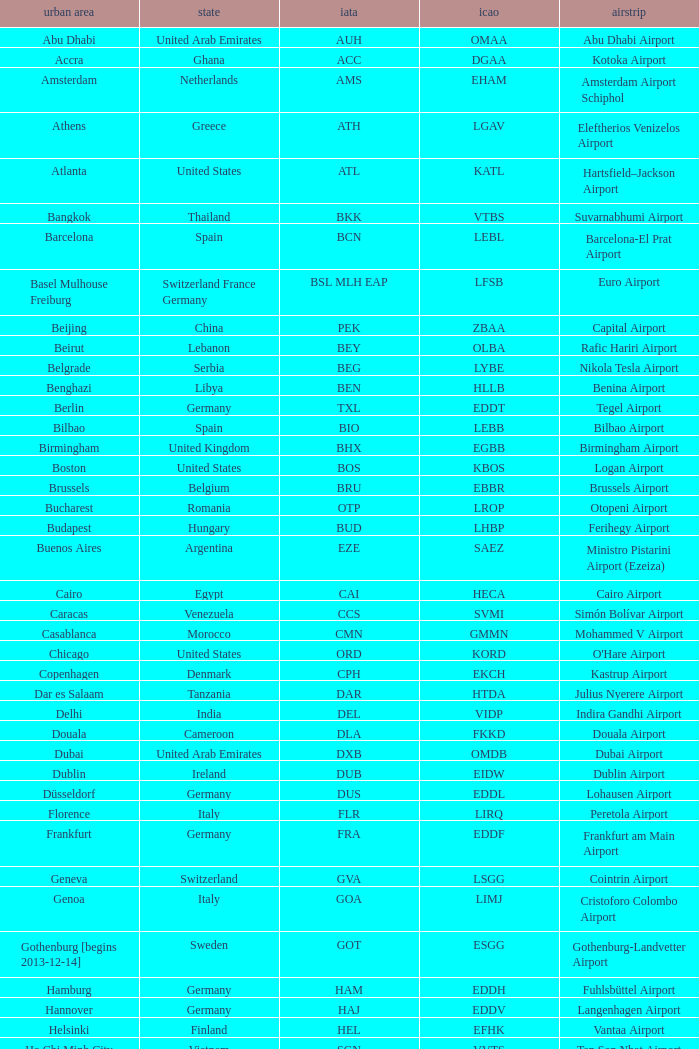What city is fuhlsbüttel airport in? Hamburg. Would you mind parsing the complete table? {'header': ['urban area', 'state', 'iata', 'icao', 'airstrip'], 'rows': [['Abu Dhabi', 'United Arab Emirates', 'AUH', 'OMAA', 'Abu Dhabi Airport'], ['Accra', 'Ghana', 'ACC', 'DGAA', 'Kotoka Airport'], ['Amsterdam', 'Netherlands', 'AMS', 'EHAM', 'Amsterdam Airport Schiphol'], ['Athens', 'Greece', 'ATH', 'LGAV', 'Eleftherios Venizelos Airport'], ['Atlanta', 'United States', 'ATL', 'KATL', 'Hartsfield–Jackson Airport'], ['Bangkok', 'Thailand', 'BKK', 'VTBS', 'Suvarnabhumi Airport'], ['Barcelona', 'Spain', 'BCN', 'LEBL', 'Barcelona-El Prat Airport'], ['Basel Mulhouse Freiburg', 'Switzerland France Germany', 'BSL MLH EAP', 'LFSB', 'Euro Airport'], ['Beijing', 'China', 'PEK', 'ZBAA', 'Capital Airport'], ['Beirut', 'Lebanon', 'BEY', 'OLBA', 'Rafic Hariri Airport'], ['Belgrade', 'Serbia', 'BEG', 'LYBE', 'Nikola Tesla Airport'], ['Benghazi', 'Libya', 'BEN', 'HLLB', 'Benina Airport'], ['Berlin', 'Germany', 'TXL', 'EDDT', 'Tegel Airport'], ['Bilbao', 'Spain', 'BIO', 'LEBB', 'Bilbao Airport'], ['Birmingham', 'United Kingdom', 'BHX', 'EGBB', 'Birmingham Airport'], ['Boston', 'United States', 'BOS', 'KBOS', 'Logan Airport'], ['Brussels', 'Belgium', 'BRU', 'EBBR', 'Brussels Airport'], ['Bucharest', 'Romania', 'OTP', 'LROP', 'Otopeni Airport'], ['Budapest', 'Hungary', 'BUD', 'LHBP', 'Ferihegy Airport'], ['Buenos Aires', 'Argentina', 'EZE', 'SAEZ', 'Ministro Pistarini Airport (Ezeiza)'], ['Cairo', 'Egypt', 'CAI', 'HECA', 'Cairo Airport'], ['Caracas', 'Venezuela', 'CCS', 'SVMI', 'Simón Bolívar Airport'], ['Casablanca', 'Morocco', 'CMN', 'GMMN', 'Mohammed V Airport'], ['Chicago', 'United States', 'ORD', 'KORD', "O'Hare Airport"], ['Copenhagen', 'Denmark', 'CPH', 'EKCH', 'Kastrup Airport'], ['Dar es Salaam', 'Tanzania', 'DAR', 'HTDA', 'Julius Nyerere Airport'], ['Delhi', 'India', 'DEL', 'VIDP', 'Indira Gandhi Airport'], ['Douala', 'Cameroon', 'DLA', 'FKKD', 'Douala Airport'], ['Dubai', 'United Arab Emirates', 'DXB', 'OMDB', 'Dubai Airport'], ['Dublin', 'Ireland', 'DUB', 'EIDW', 'Dublin Airport'], ['Düsseldorf', 'Germany', 'DUS', 'EDDL', 'Lohausen Airport'], ['Florence', 'Italy', 'FLR', 'LIRQ', 'Peretola Airport'], ['Frankfurt', 'Germany', 'FRA', 'EDDF', 'Frankfurt am Main Airport'], ['Geneva', 'Switzerland', 'GVA', 'LSGG', 'Cointrin Airport'], ['Genoa', 'Italy', 'GOA', 'LIMJ', 'Cristoforo Colombo Airport'], ['Gothenburg [begins 2013-12-14]', 'Sweden', 'GOT', 'ESGG', 'Gothenburg-Landvetter Airport'], ['Hamburg', 'Germany', 'HAM', 'EDDH', 'Fuhlsbüttel Airport'], ['Hannover', 'Germany', 'HAJ', 'EDDV', 'Langenhagen Airport'], ['Helsinki', 'Finland', 'HEL', 'EFHK', 'Vantaa Airport'], ['Ho Chi Minh City', 'Vietnam', 'SGN', 'VVTS', 'Tan Son Nhat Airport'], ['Hong Kong', 'Hong Kong', 'HKG', 'VHHH', 'Chek Lap Kok Airport'], ['Istanbul', 'Turkey', 'IST', 'LTBA', 'Atatürk Airport'], ['Jakarta', 'Indonesia', 'CGK', 'WIII', 'Soekarno–Hatta Airport'], ['Jeddah', 'Saudi Arabia', 'JED', 'OEJN', 'King Abdulaziz Airport'], ['Johannesburg', 'South Africa', 'JNB', 'FAJS', 'OR Tambo Airport'], ['Karachi', 'Pakistan', 'KHI', 'OPKC', 'Jinnah Airport'], ['Kiev', 'Ukraine', 'KBP', 'UKBB', 'Boryspil International Airport'], ['Lagos', 'Nigeria', 'LOS', 'DNMM', 'Murtala Muhammed Airport'], ['Libreville', 'Gabon', 'LBV', 'FOOL', "Leon M'ba Airport"], ['Lisbon', 'Portugal', 'LIS', 'LPPT', 'Portela Airport'], ['London', 'United Kingdom', 'LCY', 'EGLC', 'City Airport'], ['London [begins 2013-12-14]', 'United Kingdom', 'LGW', 'EGKK', 'Gatwick Airport'], ['London', 'United Kingdom', 'LHR', 'EGLL', 'Heathrow Airport'], ['Los Angeles', 'United States', 'LAX', 'KLAX', 'Los Angeles International Airport'], ['Lugano', 'Switzerland', 'LUG', 'LSZA', 'Agno Airport'], ['Luxembourg City', 'Luxembourg', 'LUX', 'ELLX', 'Findel Airport'], ['Lyon', 'France', 'LYS', 'LFLL', 'Saint-Exupéry Airport'], ['Madrid', 'Spain', 'MAD', 'LEMD', 'Madrid-Barajas Airport'], ['Malabo', 'Equatorial Guinea', 'SSG', 'FGSL', 'Saint Isabel Airport'], ['Malaga', 'Spain', 'AGP', 'LEMG', 'Málaga-Costa del Sol Airport'], ['Manchester', 'United Kingdom', 'MAN', 'EGCC', 'Ringway Airport'], ['Manila', 'Philippines', 'MNL', 'RPLL', 'Ninoy Aquino Airport'], ['Marrakech [begins 2013-11-01]', 'Morocco', 'RAK', 'GMMX', 'Menara Airport'], ['Miami', 'United States', 'MIA', 'KMIA', 'Miami Airport'], ['Milan', 'Italy', 'MXP', 'LIMC', 'Malpensa Airport'], ['Minneapolis', 'United States', 'MSP', 'KMSP', 'Minneapolis Airport'], ['Montreal', 'Canada', 'YUL', 'CYUL', 'Pierre Elliott Trudeau Airport'], ['Moscow', 'Russia', 'DME', 'UUDD', 'Domodedovo Airport'], ['Mumbai', 'India', 'BOM', 'VABB', 'Chhatrapati Shivaji Airport'], ['Munich', 'Germany', 'MUC', 'EDDM', 'Franz Josef Strauss Airport'], ['Muscat', 'Oman', 'MCT', 'OOMS', 'Seeb Airport'], ['Nairobi', 'Kenya', 'NBO', 'HKJK', 'Jomo Kenyatta Airport'], ['Newark', 'United States', 'EWR', 'KEWR', 'Liberty Airport'], ['New York City', 'United States', 'JFK', 'KJFK', 'John F Kennedy Airport'], ['Nice', 'France', 'NCE', 'LFMN', "Côte d'Azur Airport"], ['Nuremberg', 'Germany', 'NUE', 'EDDN', 'Nuremberg Airport'], ['Oslo', 'Norway', 'OSL', 'ENGM', 'Gardermoen Airport'], ['Palma de Mallorca', 'Spain', 'PMI', 'LFPA', 'Palma de Mallorca Airport'], ['Paris', 'France', 'CDG', 'LFPG', 'Charles de Gaulle Airport'], ['Porto', 'Portugal', 'OPO', 'LPPR', 'Francisco de Sa Carneiro Airport'], ['Prague', 'Czech Republic', 'PRG', 'LKPR', 'Ruzyně Airport'], ['Riga', 'Latvia', 'RIX', 'EVRA', 'Riga Airport'], ['Rio de Janeiro [resumes 2014-7-14]', 'Brazil', 'GIG', 'SBGL', 'Galeão Airport'], ['Riyadh', 'Saudi Arabia', 'RUH', 'OERK', 'King Khalid Airport'], ['Rome', 'Italy', 'FCO', 'LIRF', 'Leonardo da Vinci Airport'], ['Saint Petersburg', 'Russia', 'LED', 'ULLI', 'Pulkovo Airport'], ['San Francisco', 'United States', 'SFO', 'KSFO', 'San Francisco Airport'], ['Santiago', 'Chile', 'SCL', 'SCEL', 'Comodoro Arturo Benitez Airport'], ['São Paulo', 'Brazil', 'GRU', 'SBGR', 'Guarulhos Airport'], ['Sarajevo', 'Bosnia and Herzegovina', 'SJJ', 'LQSA', 'Butmir Airport'], ['Seattle', 'United States', 'SEA', 'KSEA', 'Sea-Tac Airport'], ['Shanghai', 'China', 'PVG', 'ZSPD', 'Pudong Airport'], ['Singapore', 'Singapore', 'SIN', 'WSSS', 'Changi Airport'], ['Skopje', 'Republic of Macedonia', 'SKP', 'LWSK', 'Alexander the Great Airport'], ['Sofia', 'Bulgaria', 'SOF', 'LBSF', 'Vrazhdebna Airport'], ['Stockholm', 'Sweden', 'ARN', 'ESSA', 'Arlanda Airport'], ['Stuttgart', 'Germany', 'STR', 'EDDS', 'Echterdingen Airport'], ['Taipei', 'Taiwan', 'TPE', 'RCTP', 'Taoyuan Airport'], ['Tehran', 'Iran', 'IKA', 'OIIE', 'Imam Khomeini Airport'], ['Tel Aviv', 'Israel', 'TLV', 'LLBG', 'Ben Gurion Airport'], ['Thessaloniki', 'Greece', 'SKG', 'LGTS', 'Macedonia Airport'], ['Tirana', 'Albania', 'TIA', 'LATI', 'Nënë Tereza Airport'], ['Tokyo', 'Japan', 'NRT', 'RJAA', 'Narita Airport'], ['Toronto', 'Canada', 'YYZ', 'CYYZ', 'Pearson Airport'], ['Tripoli', 'Libya', 'TIP', 'HLLT', 'Tripoli Airport'], ['Tunis', 'Tunisia', 'TUN', 'DTTA', 'Carthage Airport'], ['Turin', 'Italy', 'TRN', 'LIMF', 'Sandro Pertini Airport'], ['Valencia', 'Spain', 'VLC', 'LEVC', 'Valencia Airport'], ['Venice', 'Italy', 'VCE', 'LIPZ', 'Marco Polo Airport'], ['Vienna', 'Austria', 'VIE', 'LOWW', 'Schwechat Airport'], ['Warsaw', 'Poland', 'WAW', 'EPWA', 'Frederic Chopin Airport'], ['Washington DC', 'United States', 'IAD', 'KIAD', 'Dulles Airport'], ['Yaounde', 'Cameroon', 'NSI', 'FKYS', 'Yaounde Nsimalen Airport'], ['Yerevan', 'Armenia', 'EVN', 'UDYZ', 'Zvartnots Airport'], ['Zurich', 'Switzerland', 'ZRH', 'LSZH', 'Zurich Airport']]} 